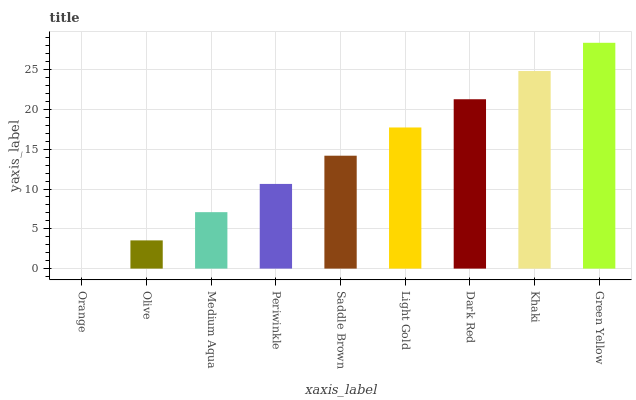Is Green Yellow the maximum?
Answer yes or no. Yes. Is Olive the minimum?
Answer yes or no. No. Is Olive the maximum?
Answer yes or no. No. Is Olive greater than Orange?
Answer yes or no. Yes. Is Orange less than Olive?
Answer yes or no. Yes. Is Orange greater than Olive?
Answer yes or no. No. Is Olive less than Orange?
Answer yes or no. No. Is Saddle Brown the high median?
Answer yes or no. Yes. Is Saddle Brown the low median?
Answer yes or no. Yes. Is Medium Aqua the high median?
Answer yes or no. No. Is Light Gold the low median?
Answer yes or no. No. 